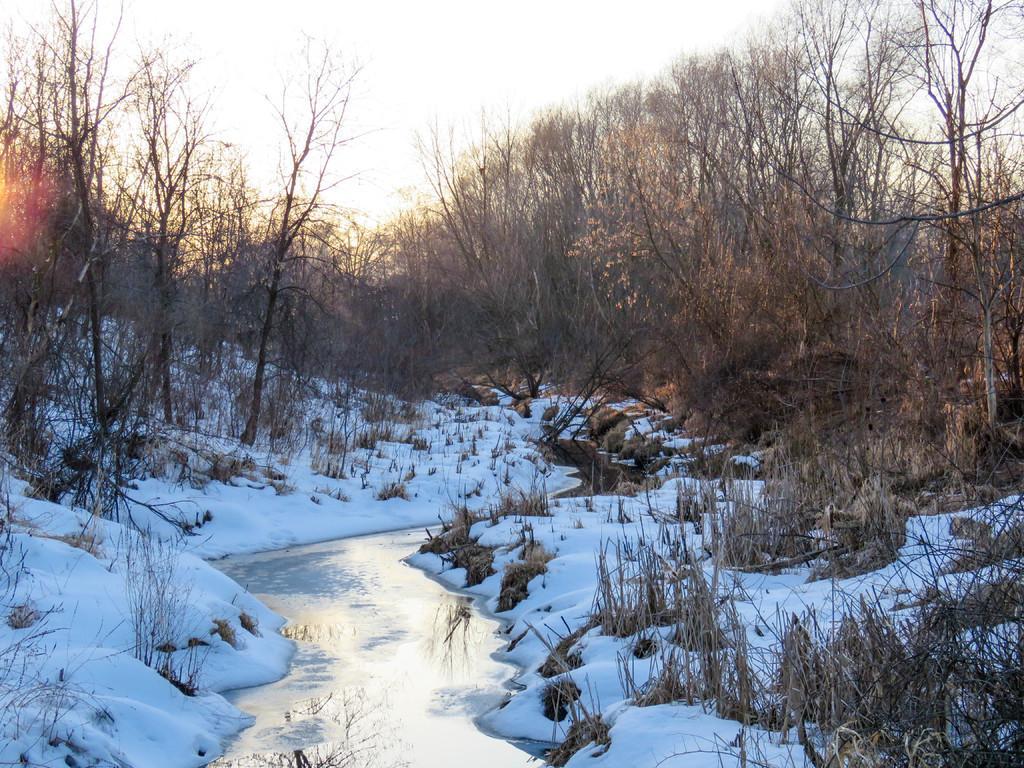In one or two sentences, can you explain what this image depicts? In this picture I can see the water in the center and I see the snow and I see number of plants and trees. In the background I can see the sky. 